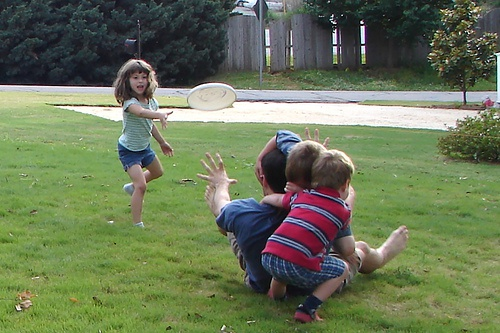Describe the objects in this image and their specific colors. I can see people in black, maroon, gray, and brown tones, people in black, navy, darkgray, and olive tones, people in black, gray, and darkgray tones, people in black, gray, and ivory tones, and frisbee in black, lightgray, and darkgray tones in this image. 